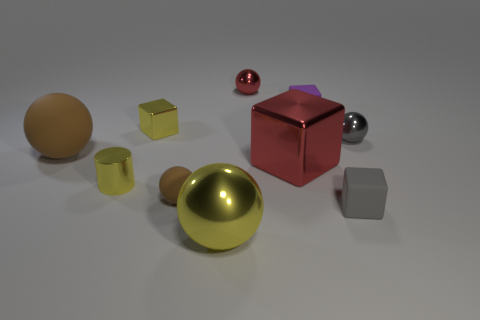There is a small rubber cube that is behind the small gray metallic ball; is it the same color as the small cylinder?
Your answer should be very brief. No. There is a block that is behind the big brown object and on the right side of the large red block; what material is it made of?
Your response must be concise. Rubber. Are there any gray metallic spheres behind the small metallic thing right of the gray cube?
Keep it short and to the point. No. Is the material of the tiny gray ball the same as the big brown sphere?
Offer a terse response. No. The object that is on the left side of the tiny metallic cube and in front of the large brown sphere has what shape?
Make the answer very short. Cylinder. There is a metal ball that is behind the tiny metallic object right of the big cube; what size is it?
Provide a short and direct response. Small. What number of red shiny objects are the same shape as the big brown object?
Ensure brevity in your answer.  1. Is the small shiny cylinder the same color as the small rubber ball?
Your answer should be compact. No. Is there any other thing that has the same shape as the big yellow metallic thing?
Offer a terse response. Yes. Are there any other large rubber things that have the same color as the large rubber object?
Provide a succinct answer. No. 